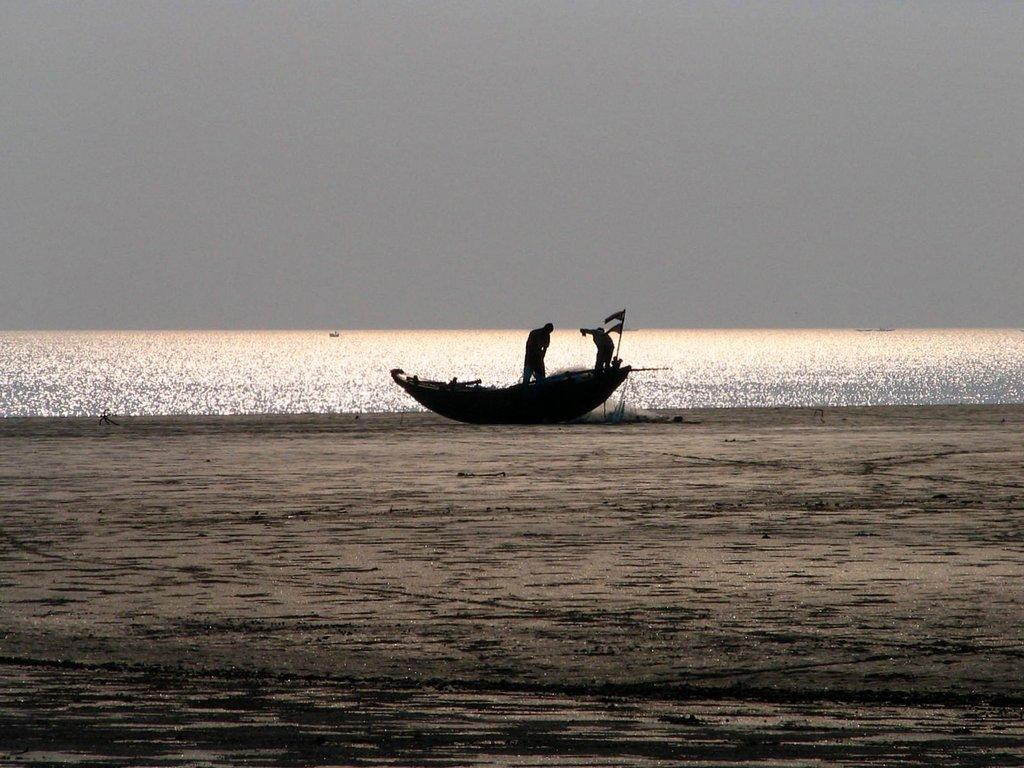How many people are in the boat in the image? There are two persons in the boat. What can be seen flying in the image? Flags are visible in the image. What type of terrain is visible in the background of the image? There is sand in the background of the image. What natural element is present in the background of the image? There is water in the background of the image. What is visible in the sky in the image? The sky is plain and visible in the background of the image. Where is the print located on the boat in the image? There is no print present on the boat in the image. What type of spot can be seen on the water in the image? There are no spots visible on the water in the image. 